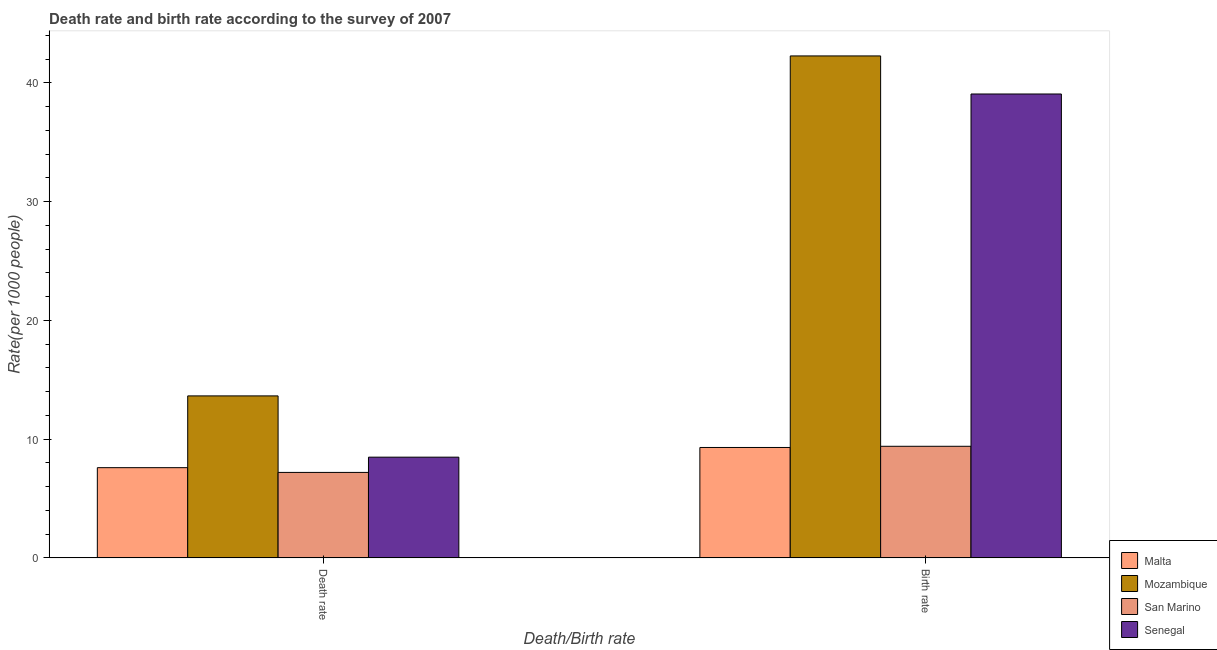How many different coloured bars are there?
Offer a very short reply. 4. How many groups of bars are there?
Your answer should be very brief. 2. Are the number of bars per tick equal to the number of legend labels?
Offer a terse response. Yes. How many bars are there on the 1st tick from the right?
Your response must be concise. 4. What is the label of the 1st group of bars from the left?
Ensure brevity in your answer.  Death rate. What is the death rate in Senegal?
Make the answer very short. 8.48. Across all countries, what is the maximum death rate?
Give a very brief answer. 13.64. In which country was the birth rate maximum?
Give a very brief answer. Mozambique. In which country was the death rate minimum?
Offer a very short reply. San Marino. What is the total death rate in the graph?
Your response must be concise. 36.93. What is the difference between the death rate in San Marino and that in Mozambique?
Give a very brief answer. -6.44. What is the difference between the death rate in Mozambique and the birth rate in Malta?
Provide a short and direct response. 4.34. What is the average birth rate per country?
Your answer should be very brief. 25.01. What is the difference between the death rate and birth rate in San Marino?
Offer a very short reply. -2.2. In how many countries, is the birth rate greater than 22 ?
Ensure brevity in your answer.  2. What is the ratio of the death rate in Mozambique to that in Senegal?
Provide a succinct answer. 1.61. In how many countries, is the birth rate greater than the average birth rate taken over all countries?
Ensure brevity in your answer.  2. What does the 1st bar from the left in Death rate represents?
Offer a very short reply. Malta. What does the 1st bar from the right in Death rate represents?
Make the answer very short. Senegal. How many countries are there in the graph?
Give a very brief answer. 4. Does the graph contain any zero values?
Ensure brevity in your answer.  No. Where does the legend appear in the graph?
Provide a succinct answer. Bottom right. How many legend labels are there?
Give a very brief answer. 4. What is the title of the graph?
Give a very brief answer. Death rate and birth rate according to the survey of 2007. Does "Norway" appear as one of the legend labels in the graph?
Your answer should be very brief. No. What is the label or title of the X-axis?
Your answer should be very brief. Death/Birth rate. What is the label or title of the Y-axis?
Your answer should be compact. Rate(per 1000 people). What is the Rate(per 1000 people) of Mozambique in Death rate?
Give a very brief answer. 13.64. What is the Rate(per 1000 people) of San Marino in Death rate?
Give a very brief answer. 7.2. What is the Rate(per 1000 people) in Senegal in Death rate?
Your answer should be very brief. 8.48. What is the Rate(per 1000 people) in Malta in Birth rate?
Keep it short and to the point. 9.3. What is the Rate(per 1000 people) of Mozambique in Birth rate?
Ensure brevity in your answer.  42.28. What is the Rate(per 1000 people) of Senegal in Birth rate?
Provide a succinct answer. 39.07. Across all Death/Birth rate, what is the maximum Rate(per 1000 people) in Malta?
Your answer should be very brief. 9.3. Across all Death/Birth rate, what is the maximum Rate(per 1000 people) in Mozambique?
Your response must be concise. 42.28. Across all Death/Birth rate, what is the maximum Rate(per 1000 people) of Senegal?
Offer a very short reply. 39.07. Across all Death/Birth rate, what is the minimum Rate(per 1000 people) of Mozambique?
Provide a succinct answer. 13.64. Across all Death/Birth rate, what is the minimum Rate(per 1000 people) in Senegal?
Keep it short and to the point. 8.48. What is the total Rate(per 1000 people) in Mozambique in the graph?
Ensure brevity in your answer.  55.92. What is the total Rate(per 1000 people) in San Marino in the graph?
Your response must be concise. 16.6. What is the total Rate(per 1000 people) in Senegal in the graph?
Ensure brevity in your answer.  47.55. What is the difference between the Rate(per 1000 people) in Mozambique in Death rate and that in Birth rate?
Your answer should be very brief. -28.63. What is the difference between the Rate(per 1000 people) in Senegal in Death rate and that in Birth rate?
Give a very brief answer. -30.59. What is the difference between the Rate(per 1000 people) in Malta in Death rate and the Rate(per 1000 people) in Mozambique in Birth rate?
Your response must be concise. -34.68. What is the difference between the Rate(per 1000 people) of Malta in Death rate and the Rate(per 1000 people) of Senegal in Birth rate?
Your answer should be very brief. -31.47. What is the difference between the Rate(per 1000 people) of Mozambique in Death rate and the Rate(per 1000 people) of San Marino in Birth rate?
Your answer should be compact. 4.24. What is the difference between the Rate(per 1000 people) in Mozambique in Death rate and the Rate(per 1000 people) in Senegal in Birth rate?
Make the answer very short. -25.43. What is the difference between the Rate(per 1000 people) of San Marino in Death rate and the Rate(per 1000 people) of Senegal in Birth rate?
Provide a succinct answer. -31.87. What is the average Rate(per 1000 people) in Malta per Death/Birth rate?
Keep it short and to the point. 8.45. What is the average Rate(per 1000 people) in Mozambique per Death/Birth rate?
Ensure brevity in your answer.  27.96. What is the average Rate(per 1000 people) in San Marino per Death/Birth rate?
Keep it short and to the point. 8.3. What is the average Rate(per 1000 people) in Senegal per Death/Birth rate?
Provide a short and direct response. 23.78. What is the difference between the Rate(per 1000 people) in Malta and Rate(per 1000 people) in Mozambique in Death rate?
Provide a succinct answer. -6.04. What is the difference between the Rate(per 1000 people) of Malta and Rate(per 1000 people) of Senegal in Death rate?
Provide a short and direct response. -0.88. What is the difference between the Rate(per 1000 people) of Mozambique and Rate(per 1000 people) of San Marino in Death rate?
Your response must be concise. 6.44. What is the difference between the Rate(per 1000 people) in Mozambique and Rate(per 1000 people) in Senegal in Death rate?
Ensure brevity in your answer.  5.16. What is the difference between the Rate(per 1000 people) of San Marino and Rate(per 1000 people) of Senegal in Death rate?
Ensure brevity in your answer.  -1.28. What is the difference between the Rate(per 1000 people) of Malta and Rate(per 1000 people) of Mozambique in Birth rate?
Provide a succinct answer. -32.98. What is the difference between the Rate(per 1000 people) of Malta and Rate(per 1000 people) of San Marino in Birth rate?
Your answer should be compact. -0.1. What is the difference between the Rate(per 1000 people) in Malta and Rate(per 1000 people) in Senegal in Birth rate?
Your answer should be compact. -29.77. What is the difference between the Rate(per 1000 people) of Mozambique and Rate(per 1000 people) of San Marino in Birth rate?
Your answer should be compact. 32.88. What is the difference between the Rate(per 1000 people) of Mozambique and Rate(per 1000 people) of Senegal in Birth rate?
Offer a very short reply. 3.21. What is the difference between the Rate(per 1000 people) in San Marino and Rate(per 1000 people) in Senegal in Birth rate?
Your answer should be compact. -29.67. What is the ratio of the Rate(per 1000 people) of Malta in Death rate to that in Birth rate?
Keep it short and to the point. 0.82. What is the ratio of the Rate(per 1000 people) of Mozambique in Death rate to that in Birth rate?
Your answer should be very brief. 0.32. What is the ratio of the Rate(per 1000 people) in San Marino in Death rate to that in Birth rate?
Provide a succinct answer. 0.77. What is the ratio of the Rate(per 1000 people) in Senegal in Death rate to that in Birth rate?
Offer a very short reply. 0.22. What is the difference between the highest and the second highest Rate(per 1000 people) in Malta?
Ensure brevity in your answer.  1.7. What is the difference between the highest and the second highest Rate(per 1000 people) of Mozambique?
Offer a terse response. 28.63. What is the difference between the highest and the second highest Rate(per 1000 people) of Senegal?
Your response must be concise. 30.59. What is the difference between the highest and the lowest Rate(per 1000 people) in Malta?
Your answer should be compact. 1.7. What is the difference between the highest and the lowest Rate(per 1000 people) in Mozambique?
Give a very brief answer. 28.63. What is the difference between the highest and the lowest Rate(per 1000 people) in Senegal?
Your answer should be very brief. 30.59. 